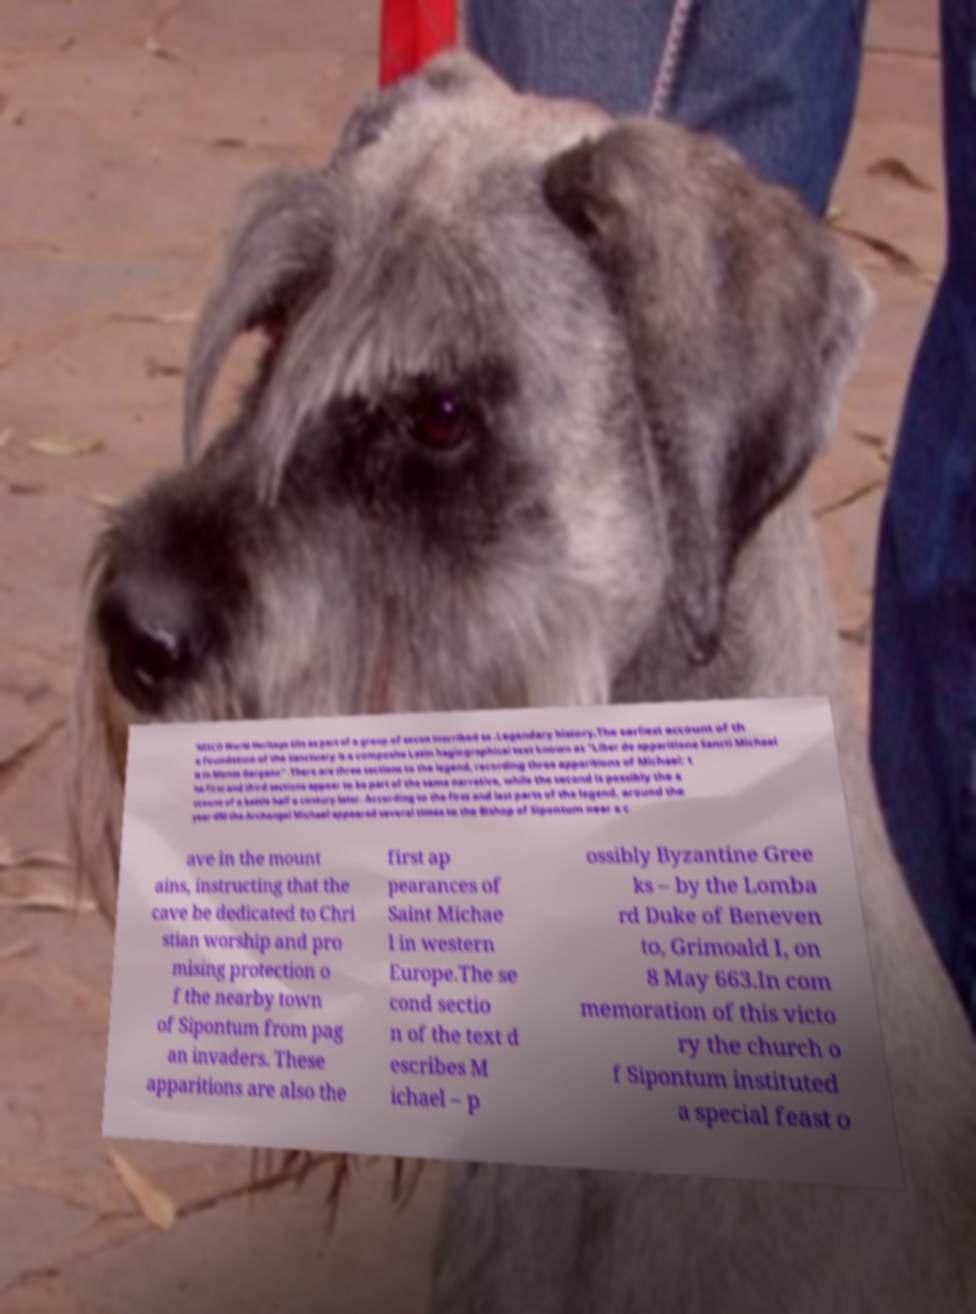What messages or text are displayed in this image? I need them in a readable, typed format. NESCO World Heritage Site as part of a group of seven inscribed as .Legendary history.The earliest account of th e foundation of the Sanctuary is a composite Latin hagiographical text known as "Liber de apparitione Sancti Michael is in Monte Gargano" .There are three sections to the legend, recording three apparitions of Michael: t he first and third sections appear to be part of the same narrative, while the second is possibly the a ccount of a battle half a century later. According to the first and last parts of the legend, around the year 490 the Archangel Michael appeared several times to the Bishop of Sipontum near a c ave in the mount ains, instructing that the cave be dedicated to Chri stian worship and pro mising protection o f the nearby town of Sipontum from pag an invaders. These apparitions are also the first ap pearances of Saint Michae l in western Europe.The se cond sectio n of the text d escribes M ichael – p ossibly Byzantine Gree ks – by the Lomba rd Duke of Beneven to, Grimoald I, on 8 May 663.In com memoration of this victo ry the church o f Sipontum instituted a special feast o 